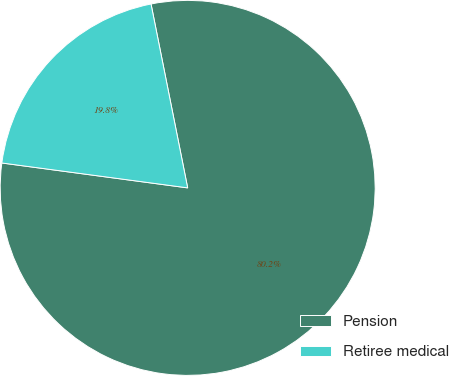<chart> <loc_0><loc_0><loc_500><loc_500><pie_chart><fcel>Pension<fcel>Retiree medical<nl><fcel>80.25%<fcel>19.75%<nl></chart> 